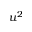<formula> <loc_0><loc_0><loc_500><loc_500>u ^ { 2 }</formula> 